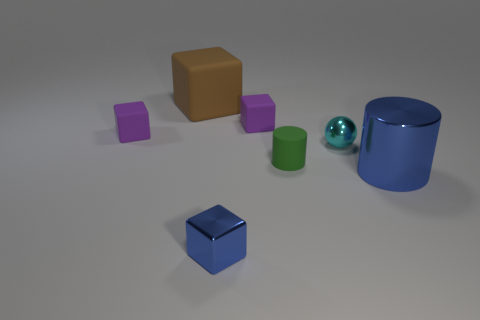How many green cylinders are on the right side of the purple cube left of the metallic block?
Ensure brevity in your answer.  1. What number of things are both behind the tiny blue cube and right of the large brown rubber thing?
Provide a succinct answer. 4. What number of things are either tiny blocks in front of the shiny sphere or small cubes that are behind the small green cylinder?
Provide a short and direct response. 3. How many other things are there of the same size as the blue cube?
Ensure brevity in your answer.  4. The shiny object that is behind the metallic thing right of the cyan metal sphere is what shape?
Give a very brief answer. Sphere. There is a shiny thing that is to the left of the green object; is its color the same as the tiny metallic object that is behind the tiny green object?
Your response must be concise. No. Are there any other things that are the same color as the small ball?
Ensure brevity in your answer.  No. The metallic cylinder is what color?
Give a very brief answer. Blue. Is there a red metal cylinder?
Give a very brief answer. No. There is a small cylinder; are there any tiny matte cubes on the right side of it?
Keep it short and to the point. No. 